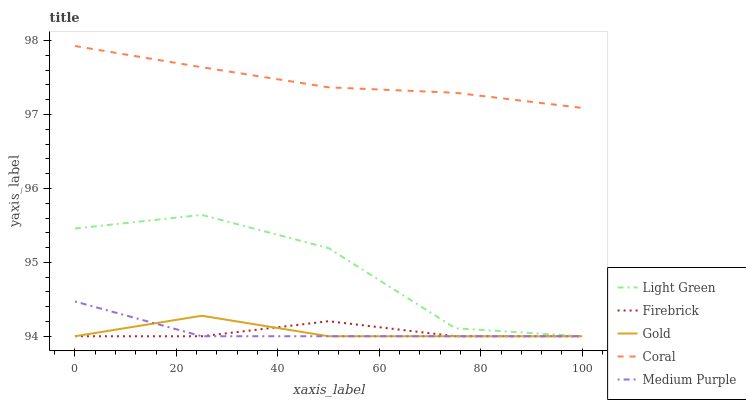Does Firebrick have the minimum area under the curve?
Answer yes or no. Yes. Does Coral have the maximum area under the curve?
Answer yes or no. Yes. Does Medium Purple have the minimum area under the curve?
Answer yes or no. No. Does Medium Purple have the maximum area under the curve?
Answer yes or no. No. Is Coral the smoothest?
Answer yes or no. Yes. Is Light Green the roughest?
Answer yes or no. Yes. Is Medium Purple the smoothest?
Answer yes or no. No. Is Medium Purple the roughest?
Answer yes or no. No. Does Medium Purple have the lowest value?
Answer yes or no. Yes. Does Coral have the highest value?
Answer yes or no. Yes. Does Medium Purple have the highest value?
Answer yes or no. No. Is Medium Purple less than Coral?
Answer yes or no. Yes. Is Coral greater than Firebrick?
Answer yes or no. Yes. Does Gold intersect Medium Purple?
Answer yes or no. Yes. Is Gold less than Medium Purple?
Answer yes or no. No. Is Gold greater than Medium Purple?
Answer yes or no. No. Does Medium Purple intersect Coral?
Answer yes or no. No. 